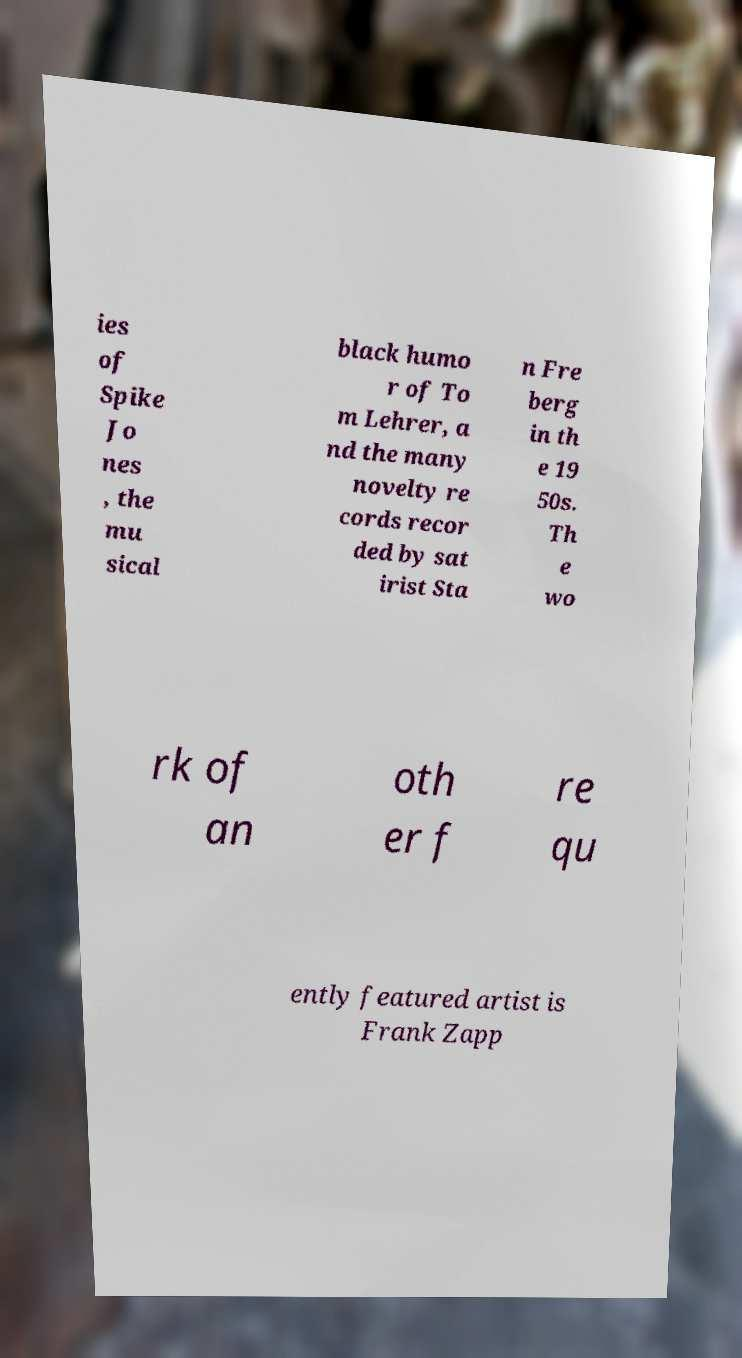I need the written content from this picture converted into text. Can you do that? ies of Spike Jo nes , the mu sical black humo r of To m Lehrer, a nd the many novelty re cords recor ded by sat irist Sta n Fre berg in th e 19 50s. Th e wo rk of an oth er f re qu ently featured artist is Frank Zapp 